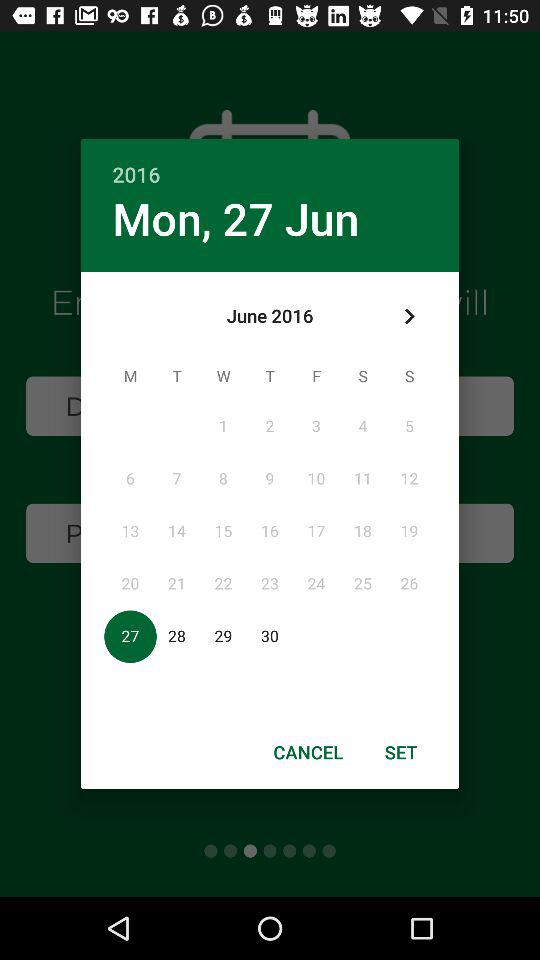What is the day on the selected date? The day is Monday. 